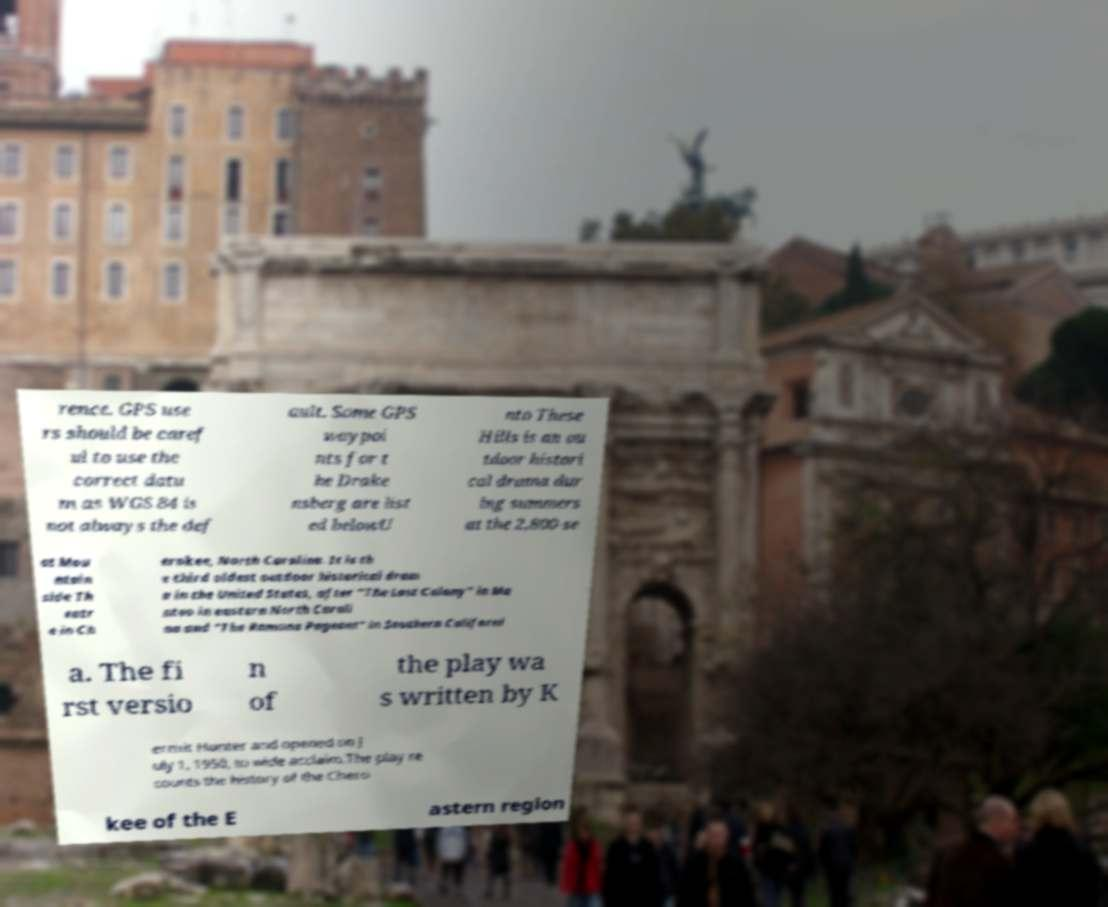Could you extract and type out the text from this image? rence. GPS use rs should be caref ul to use the correct datu m as WGS 84 is not always the def ault. Some GPS waypoi nts for t he Drake nsberg are list ed belowU nto These Hills is an ou tdoor histori cal drama dur ing summers at the 2,800-se at Mou ntain side Th eatr e in Ch erokee, North Carolina. It is th e third oldest outdoor historical dram a in the United States, after "The Lost Colony" in Ma nteo in eastern North Caroli na and "The Ramona Pageant" in Southern Californi a. The fi rst versio n of the play wa s written by K ermit Hunter and opened on J uly 1, 1950, to wide acclaim.The play re counts the history of the Chero kee of the E astern region 